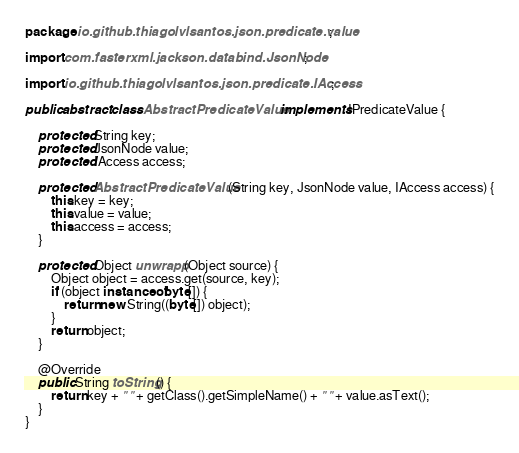Convert code to text. <code><loc_0><loc_0><loc_500><loc_500><_Java_>package io.github.thiagolvlsantos.json.predicate.value;

import com.fasterxml.jackson.databind.JsonNode;

import io.github.thiagolvlsantos.json.predicate.IAccess;

public abstract class AbstractPredicateValue implements IPredicateValue {

	protected String key;
	protected JsonNode value;
	protected IAccess access;

	protected AbstractPredicateValue(String key, JsonNode value, IAccess access) {
		this.key = key;
		this.value = value;
		this.access = access;
	}

	protected Object unwrapp(Object source) {
		Object object = access.get(source, key);
		if (object instanceof byte[]) {
			return new String((byte[]) object);
		}
		return object;
	}

	@Override
	public String toString() {
		return key + " " + getClass().getSimpleName() + " " + value.asText();
	}
}</code> 